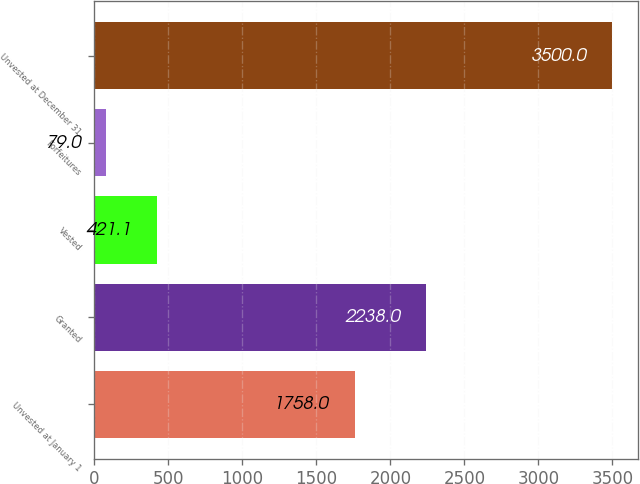Convert chart to OTSL. <chart><loc_0><loc_0><loc_500><loc_500><bar_chart><fcel>Unvested at January 1<fcel>Granted<fcel>Vested<fcel>Forfeitures<fcel>Unvested at December 31<nl><fcel>1758<fcel>2238<fcel>421.1<fcel>79<fcel>3500<nl></chart> 